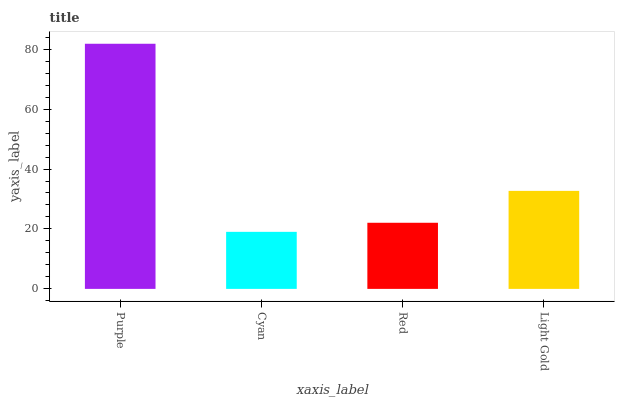Is Cyan the minimum?
Answer yes or no. Yes. Is Purple the maximum?
Answer yes or no. Yes. Is Red the minimum?
Answer yes or no. No. Is Red the maximum?
Answer yes or no. No. Is Red greater than Cyan?
Answer yes or no. Yes. Is Cyan less than Red?
Answer yes or no. Yes. Is Cyan greater than Red?
Answer yes or no. No. Is Red less than Cyan?
Answer yes or no. No. Is Light Gold the high median?
Answer yes or no. Yes. Is Red the low median?
Answer yes or no. Yes. Is Purple the high median?
Answer yes or no. No. Is Light Gold the low median?
Answer yes or no. No. 